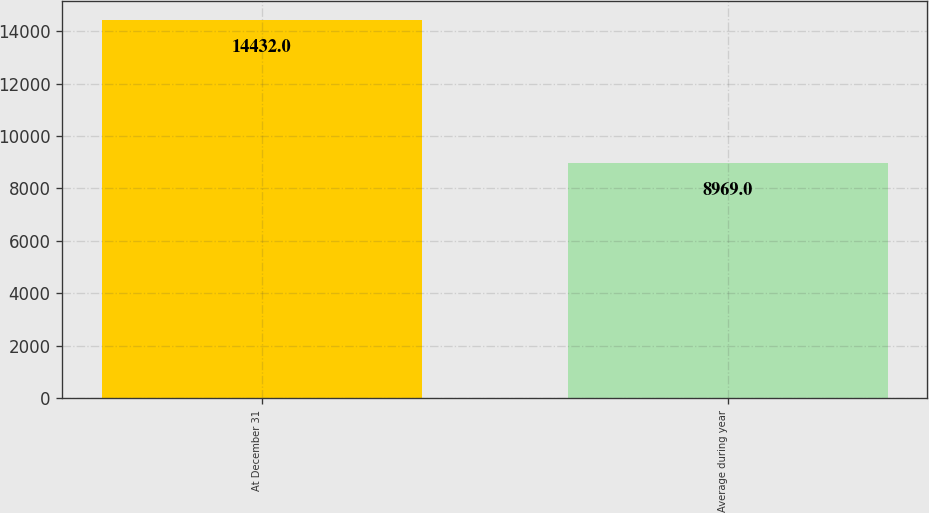Convert chart to OTSL. <chart><loc_0><loc_0><loc_500><loc_500><bar_chart><fcel>At December 31<fcel>Average during year<nl><fcel>14432<fcel>8969<nl></chart> 